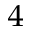<formula> <loc_0><loc_0><loc_500><loc_500>_ { 4 }</formula> 